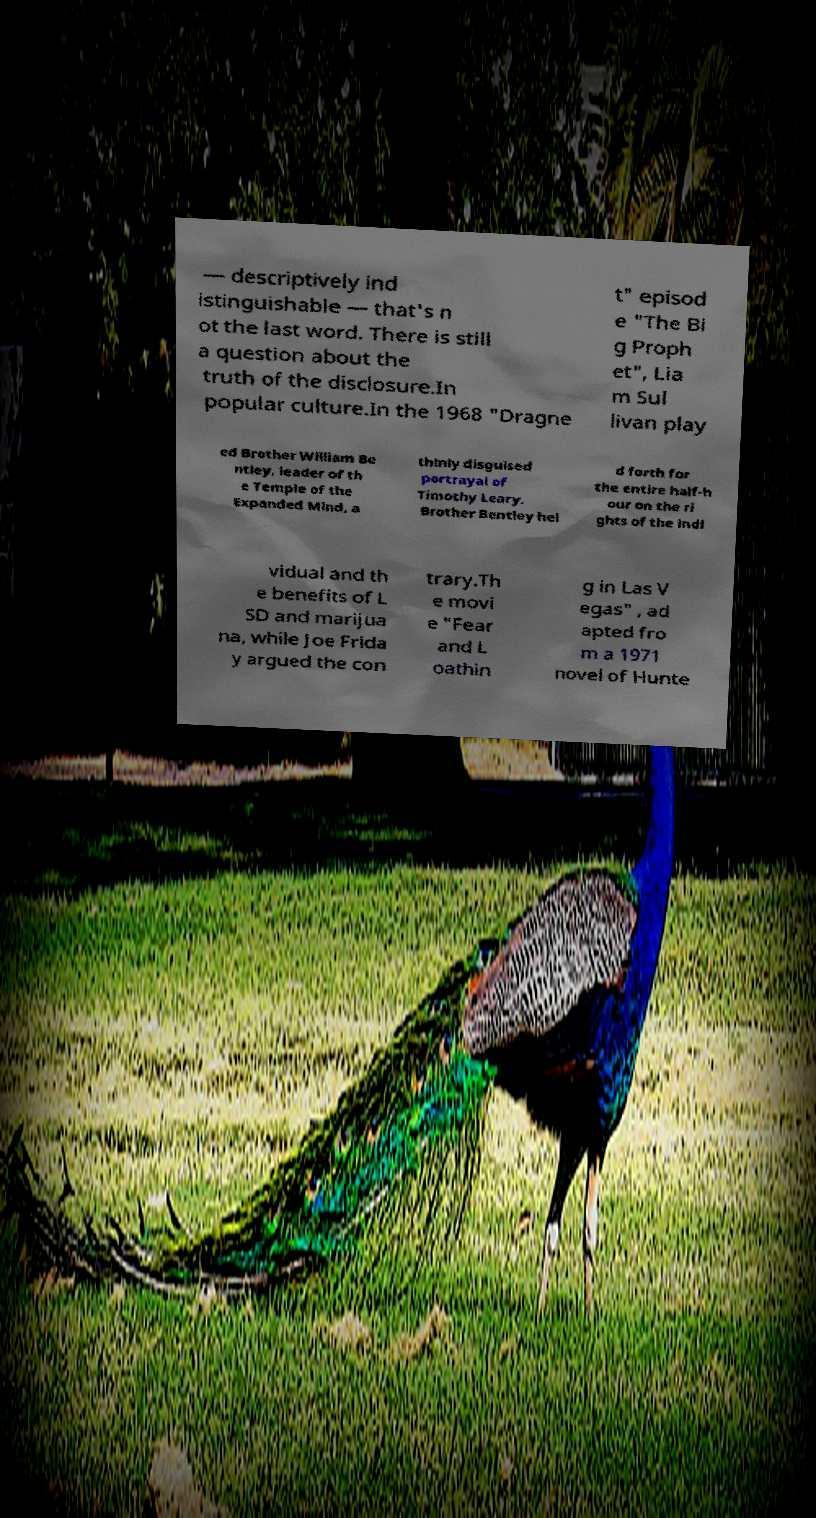What messages or text are displayed in this image? I need them in a readable, typed format. — descriptively ind istinguishable — that's n ot the last word. There is still a question about the truth of the disclosure.In popular culture.In the 1968 "Dragne t" episod e "The Bi g Proph et", Lia m Sul livan play ed Brother William Be ntley, leader of th e Temple of the Expanded Mind, a thinly disguised portrayal of Timothy Leary. Brother Bentley hel d forth for the entire half-h our on the ri ghts of the indi vidual and th e benefits of L SD and marijua na, while Joe Frida y argued the con trary.Th e movi e "Fear and L oathin g in Las V egas" , ad apted fro m a 1971 novel of Hunte 